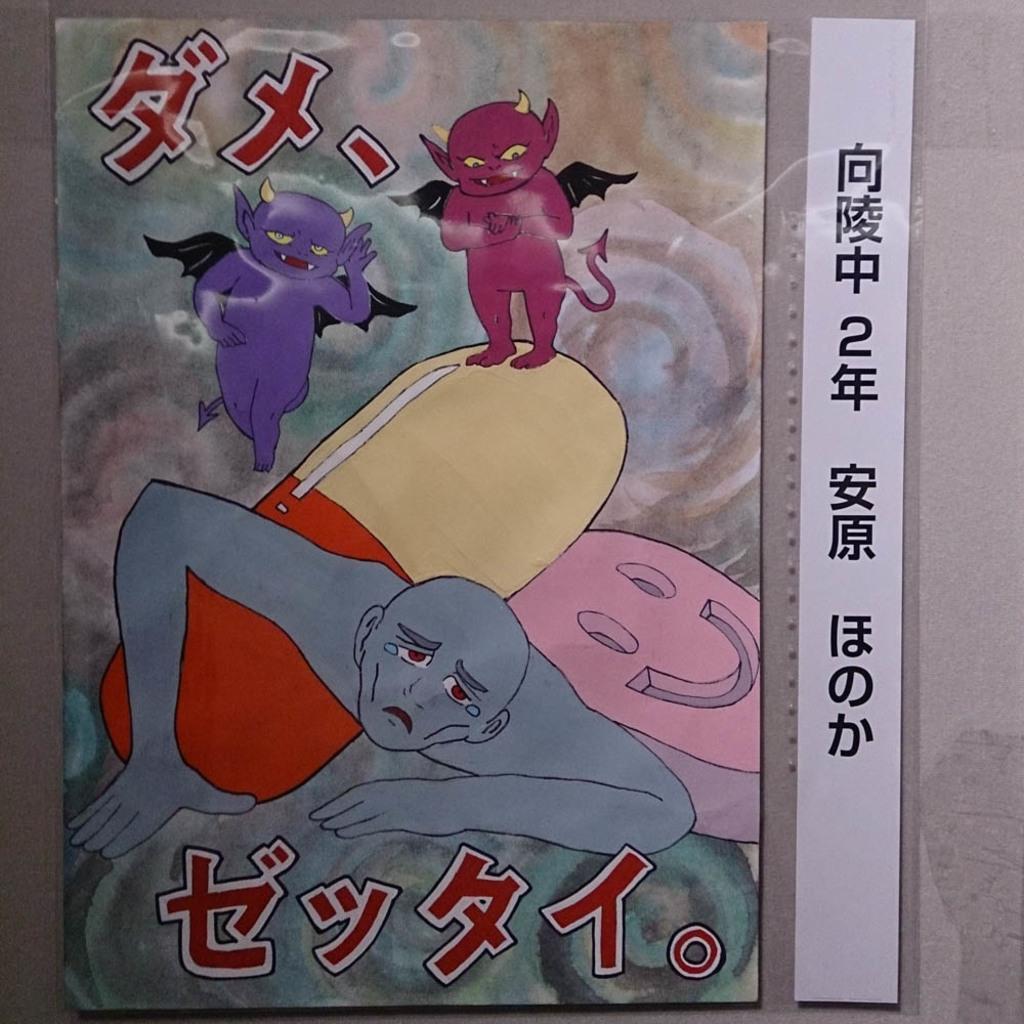Describe this image in one or two sentences. In this image we can see the poster of cartoon pictures and also the text. In the background we can see the wall. 